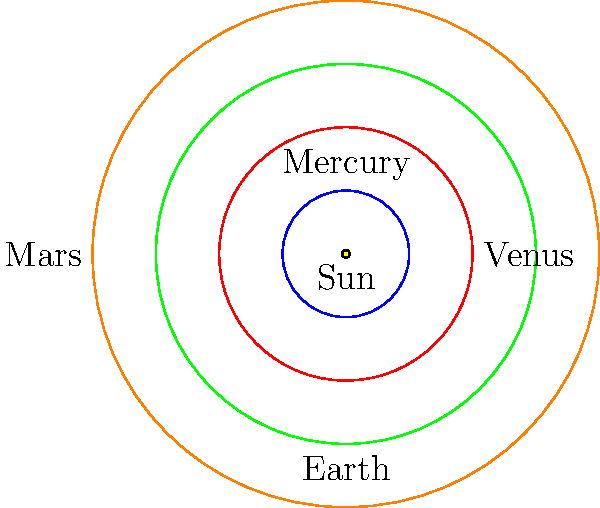In the simplified orbital diagram of the inner Solar System shown above, which planet's orbit is represented by the green circle? To answer this question, let's analyze the diagram step-by-step:

1. The diagram shows a simplified representation of the inner Solar System.
2. The yellow dot at the center represents the Sun.
3. There are four concentric circles representing the orbits of the inner planets.
4. The circles are colored blue, red, green, and orange, moving outward from the Sun.
5. The planets are labeled in order of their distance from the Sun:
   - Mercury is closest to the Sun, on the blue orbit.
   - Venus is second, on the red orbit.
   - Earth is third, on the green orbit.
   - Mars is farthest, on the orange orbit.
6. The question asks specifically about the green circle.
7. By matching the color to the planet, we can see that Earth's orbit is represented by the green circle.

Therefore, the planet whose orbit is represented by the green circle is Earth.
Answer: Earth 